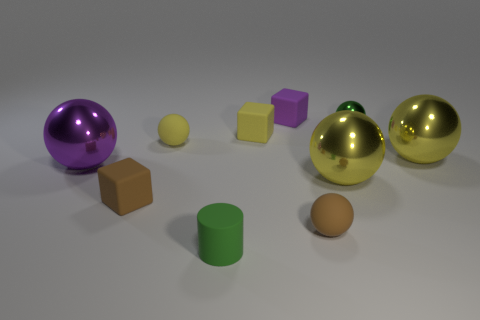Which object stands out the most in this composition? The reflective golden spheres immediately draw the eye due to their sheen and size, making them the most prominent objects in this assembly. 